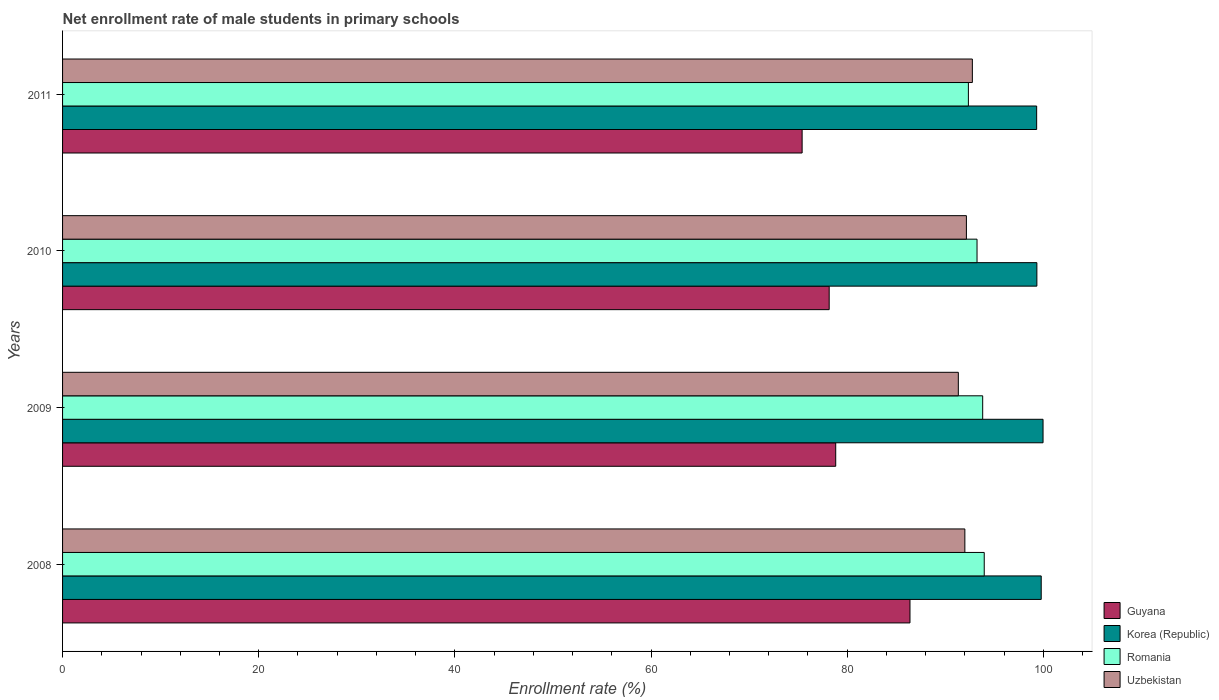Are the number of bars per tick equal to the number of legend labels?
Your answer should be very brief. Yes. Are the number of bars on each tick of the Y-axis equal?
Ensure brevity in your answer.  Yes. How many bars are there on the 2nd tick from the bottom?
Offer a terse response. 4. What is the label of the 1st group of bars from the top?
Make the answer very short. 2011. In how many cases, is the number of bars for a given year not equal to the number of legend labels?
Provide a short and direct response. 0. What is the net enrollment rate of male students in primary schools in Guyana in 2010?
Make the answer very short. 78.17. Across all years, what is the maximum net enrollment rate of male students in primary schools in Uzbekistan?
Keep it short and to the point. 92.76. Across all years, what is the minimum net enrollment rate of male students in primary schools in Romania?
Keep it short and to the point. 92.36. What is the total net enrollment rate of male students in primary schools in Uzbekistan in the graph?
Make the answer very short. 368.26. What is the difference between the net enrollment rate of male students in primary schools in Romania in 2010 and that in 2011?
Provide a succinct answer. 0.88. What is the difference between the net enrollment rate of male students in primary schools in Korea (Republic) in 2010 and the net enrollment rate of male students in primary schools in Uzbekistan in 2011?
Make the answer very short. 6.58. What is the average net enrollment rate of male students in primary schools in Guyana per year?
Your answer should be very brief. 79.7. In the year 2011, what is the difference between the net enrollment rate of male students in primary schools in Korea (Republic) and net enrollment rate of male students in primary schools in Romania?
Ensure brevity in your answer.  6.96. In how many years, is the net enrollment rate of male students in primary schools in Korea (Republic) greater than 80 %?
Provide a short and direct response. 4. What is the ratio of the net enrollment rate of male students in primary schools in Korea (Republic) in 2008 to that in 2010?
Offer a terse response. 1. Is the net enrollment rate of male students in primary schools in Uzbekistan in 2008 less than that in 2010?
Your answer should be very brief. Yes. Is the difference between the net enrollment rate of male students in primary schools in Korea (Republic) in 2009 and 2011 greater than the difference between the net enrollment rate of male students in primary schools in Romania in 2009 and 2011?
Ensure brevity in your answer.  No. What is the difference between the highest and the second highest net enrollment rate of male students in primary schools in Uzbekistan?
Ensure brevity in your answer.  0.61. What is the difference between the highest and the lowest net enrollment rate of male students in primary schools in Romania?
Make the answer very short. 1.61. Is it the case that in every year, the sum of the net enrollment rate of male students in primary schools in Korea (Republic) and net enrollment rate of male students in primary schools in Guyana is greater than the sum of net enrollment rate of male students in primary schools in Uzbekistan and net enrollment rate of male students in primary schools in Romania?
Your response must be concise. No. What does the 1st bar from the top in 2009 represents?
Give a very brief answer. Uzbekistan. How many bars are there?
Provide a short and direct response. 16. How many years are there in the graph?
Offer a very short reply. 4. What is the difference between two consecutive major ticks on the X-axis?
Your answer should be compact. 20. Does the graph contain any zero values?
Provide a short and direct response. No. Does the graph contain grids?
Offer a very short reply. No. Where does the legend appear in the graph?
Give a very brief answer. Bottom right. How many legend labels are there?
Your response must be concise. 4. What is the title of the graph?
Your answer should be compact. Net enrollment rate of male students in primary schools. Does "Middle East & North Africa (all income levels)" appear as one of the legend labels in the graph?
Give a very brief answer. No. What is the label or title of the X-axis?
Make the answer very short. Enrollment rate (%). What is the label or title of the Y-axis?
Give a very brief answer. Years. What is the Enrollment rate (%) of Guyana in 2008?
Offer a very short reply. 86.4. What is the Enrollment rate (%) of Korea (Republic) in 2008?
Make the answer very short. 99.78. What is the Enrollment rate (%) in Romania in 2008?
Offer a very short reply. 93.98. What is the Enrollment rate (%) of Uzbekistan in 2008?
Give a very brief answer. 92. What is the Enrollment rate (%) of Guyana in 2009?
Your answer should be compact. 78.83. What is the Enrollment rate (%) in Korea (Republic) in 2009?
Your response must be concise. 99.97. What is the Enrollment rate (%) in Romania in 2009?
Keep it short and to the point. 93.82. What is the Enrollment rate (%) of Uzbekistan in 2009?
Make the answer very short. 91.33. What is the Enrollment rate (%) in Guyana in 2010?
Provide a short and direct response. 78.17. What is the Enrollment rate (%) in Korea (Republic) in 2010?
Provide a succinct answer. 99.34. What is the Enrollment rate (%) in Romania in 2010?
Your answer should be very brief. 93.24. What is the Enrollment rate (%) of Uzbekistan in 2010?
Ensure brevity in your answer.  92.16. What is the Enrollment rate (%) of Guyana in 2011?
Your response must be concise. 75.41. What is the Enrollment rate (%) of Korea (Republic) in 2011?
Offer a very short reply. 99.32. What is the Enrollment rate (%) in Romania in 2011?
Provide a succinct answer. 92.36. What is the Enrollment rate (%) of Uzbekistan in 2011?
Your answer should be very brief. 92.76. Across all years, what is the maximum Enrollment rate (%) in Guyana?
Provide a succinct answer. 86.4. Across all years, what is the maximum Enrollment rate (%) of Korea (Republic)?
Give a very brief answer. 99.97. Across all years, what is the maximum Enrollment rate (%) of Romania?
Your answer should be very brief. 93.98. Across all years, what is the maximum Enrollment rate (%) of Uzbekistan?
Provide a succinct answer. 92.76. Across all years, what is the minimum Enrollment rate (%) in Guyana?
Give a very brief answer. 75.41. Across all years, what is the minimum Enrollment rate (%) of Korea (Republic)?
Provide a short and direct response. 99.32. Across all years, what is the minimum Enrollment rate (%) of Romania?
Make the answer very short. 92.36. Across all years, what is the minimum Enrollment rate (%) in Uzbekistan?
Ensure brevity in your answer.  91.33. What is the total Enrollment rate (%) in Guyana in the graph?
Make the answer very short. 318.81. What is the total Enrollment rate (%) in Korea (Republic) in the graph?
Your answer should be compact. 398.42. What is the total Enrollment rate (%) in Romania in the graph?
Ensure brevity in your answer.  373.39. What is the total Enrollment rate (%) of Uzbekistan in the graph?
Your response must be concise. 368.26. What is the difference between the Enrollment rate (%) in Guyana in 2008 and that in 2009?
Make the answer very short. 7.57. What is the difference between the Enrollment rate (%) of Korea (Republic) in 2008 and that in 2009?
Keep it short and to the point. -0.19. What is the difference between the Enrollment rate (%) in Romania in 2008 and that in 2009?
Provide a succinct answer. 0.16. What is the difference between the Enrollment rate (%) of Guyana in 2008 and that in 2010?
Give a very brief answer. 8.24. What is the difference between the Enrollment rate (%) in Korea (Republic) in 2008 and that in 2010?
Your response must be concise. 0.44. What is the difference between the Enrollment rate (%) in Romania in 2008 and that in 2010?
Provide a succinct answer. 0.74. What is the difference between the Enrollment rate (%) in Uzbekistan in 2008 and that in 2010?
Offer a terse response. -0.16. What is the difference between the Enrollment rate (%) in Guyana in 2008 and that in 2011?
Give a very brief answer. 11. What is the difference between the Enrollment rate (%) of Korea (Republic) in 2008 and that in 2011?
Your answer should be compact. 0.46. What is the difference between the Enrollment rate (%) in Romania in 2008 and that in 2011?
Your response must be concise. 1.61. What is the difference between the Enrollment rate (%) of Uzbekistan in 2008 and that in 2011?
Provide a short and direct response. -0.76. What is the difference between the Enrollment rate (%) of Guyana in 2009 and that in 2010?
Your answer should be compact. 0.67. What is the difference between the Enrollment rate (%) in Korea (Republic) in 2009 and that in 2010?
Your answer should be very brief. 0.63. What is the difference between the Enrollment rate (%) in Romania in 2009 and that in 2010?
Offer a terse response. 0.58. What is the difference between the Enrollment rate (%) of Uzbekistan in 2009 and that in 2010?
Provide a short and direct response. -0.82. What is the difference between the Enrollment rate (%) of Guyana in 2009 and that in 2011?
Provide a succinct answer. 3.43. What is the difference between the Enrollment rate (%) in Korea (Republic) in 2009 and that in 2011?
Make the answer very short. 0.65. What is the difference between the Enrollment rate (%) of Romania in 2009 and that in 2011?
Provide a succinct answer. 1.46. What is the difference between the Enrollment rate (%) in Uzbekistan in 2009 and that in 2011?
Ensure brevity in your answer.  -1.43. What is the difference between the Enrollment rate (%) of Guyana in 2010 and that in 2011?
Your answer should be very brief. 2.76. What is the difference between the Enrollment rate (%) of Korea (Republic) in 2010 and that in 2011?
Your response must be concise. 0.02. What is the difference between the Enrollment rate (%) of Romania in 2010 and that in 2011?
Offer a terse response. 0.88. What is the difference between the Enrollment rate (%) of Uzbekistan in 2010 and that in 2011?
Ensure brevity in your answer.  -0.61. What is the difference between the Enrollment rate (%) in Guyana in 2008 and the Enrollment rate (%) in Korea (Republic) in 2009?
Provide a short and direct response. -13.57. What is the difference between the Enrollment rate (%) of Guyana in 2008 and the Enrollment rate (%) of Romania in 2009?
Provide a short and direct response. -7.41. What is the difference between the Enrollment rate (%) of Guyana in 2008 and the Enrollment rate (%) of Uzbekistan in 2009?
Ensure brevity in your answer.  -4.93. What is the difference between the Enrollment rate (%) of Korea (Republic) in 2008 and the Enrollment rate (%) of Romania in 2009?
Make the answer very short. 5.97. What is the difference between the Enrollment rate (%) of Korea (Republic) in 2008 and the Enrollment rate (%) of Uzbekistan in 2009?
Make the answer very short. 8.45. What is the difference between the Enrollment rate (%) in Romania in 2008 and the Enrollment rate (%) in Uzbekistan in 2009?
Your answer should be very brief. 2.64. What is the difference between the Enrollment rate (%) of Guyana in 2008 and the Enrollment rate (%) of Korea (Republic) in 2010?
Provide a succinct answer. -12.94. What is the difference between the Enrollment rate (%) in Guyana in 2008 and the Enrollment rate (%) in Romania in 2010?
Your answer should be compact. -6.84. What is the difference between the Enrollment rate (%) in Guyana in 2008 and the Enrollment rate (%) in Uzbekistan in 2010?
Your answer should be compact. -5.75. What is the difference between the Enrollment rate (%) in Korea (Republic) in 2008 and the Enrollment rate (%) in Romania in 2010?
Make the answer very short. 6.54. What is the difference between the Enrollment rate (%) of Korea (Republic) in 2008 and the Enrollment rate (%) of Uzbekistan in 2010?
Give a very brief answer. 7.63. What is the difference between the Enrollment rate (%) of Romania in 2008 and the Enrollment rate (%) of Uzbekistan in 2010?
Provide a succinct answer. 1.82. What is the difference between the Enrollment rate (%) of Guyana in 2008 and the Enrollment rate (%) of Korea (Republic) in 2011?
Offer a terse response. -12.92. What is the difference between the Enrollment rate (%) in Guyana in 2008 and the Enrollment rate (%) in Romania in 2011?
Your answer should be very brief. -5.96. What is the difference between the Enrollment rate (%) of Guyana in 2008 and the Enrollment rate (%) of Uzbekistan in 2011?
Provide a short and direct response. -6.36. What is the difference between the Enrollment rate (%) of Korea (Republic) in 2008 and the Enrollment rate (%) of Romania in 2011?
Make the answer very short. 7.42. What is the difference between the Enrollment rate (%) in Korea (Republic) in 2008 and the Enrollment rate (%) in Uzbekistan in 2011?
Provide a short and direct response. 7.02. What is the difference between the Enrollment rate (%) of Romania in 2008 and the Enrollment rate (%) of Uzbekistan in 2011?
Your answer should be very brief. 1.21. What is the difference between the Enrollment rate (%) of Guyana in 2009 and the Enrollment rate (%) of Korea (Republic) in 2010?
Provide a succinct answer. -20.51. What is the difference between the Enrollment rate (%) of Guyana in 2009 and the Enrollment rate (%) of Romania in 2010?
Keep it short and to the point. -14.41. What is the difference between the Enrollment rate (%) in Guyana in 2009 and the Enrollment rate (%) in Uzbekistan in 2010?
Provide a succinct answer. -13.32. What is the difference between the Enrollment rate (%) in Korea (Republic) in 2009 and the Enrollment rate (%) in Romania in 2010?
Give a very brief answer. 6.73. What is the difference between the Enrollment rate (%) in Korea (Republic) in 2009 and the Enrollment rate (%) in Uzbekistan in 2010?
Your response must be concise. 7.82. What is the difference between the Enrollment rate (%) in Romania in 2009 and the Enrollment rate (%) in Uzbekistan in 2010?
Make the answer very short. 1.66. What is the difference between the Enrollment rate (%) of Guyana in 2009 and the Enrollment rate (%) of Korea (Republic) in 2011?
Give a very brief answer. -20.49. What is the difference between the Enrollment rate (%) in Guyana in 2009 and the Enrollment rate (%) in Romania in 2011?
Your answer should be very brief. -13.53. What is the difference between the Enrollment rate (%) in Guyana in 2009 and the Enrollment rate (%) in Uzbekistan in 2011?
Provide a short and direct response. -13.93. What is the difference between the Enrollment rate (%) of Korea (Republic) in 2009 and the Enrollment rate (%) of Romania in 2011?
Make the answer very short. 7.61. What is the difference between the Enrollment rate (%) in Korea (Republic) in 2009 and the Enrollment rate (%) in Uzbekistan in 2011?
Keep it short and to the point. 7.21. What is the difference between the Enrollment rate (%) of Romania in 2009 and the Enrollment rate (%) of Uzbekistan in 2011?
Provide a succinct answer. 1.05. What is the difference between the Enrollment rate (%) in Guyana in 2010 and the Enrollment rate (%) in Korea (Republic) in 2011?
Ensure brevity in your answer.  -21.15. What is the difference between the Enrollment rate (%) in Guyana in 2010 and the Enrollment rate (%) in Romania in 2011?
Make the answer very short. -14.19. What is the difference between the Enrollment rate (%) in Guyana in 2010 and the Enrollment rate (%) in Uzbekistan in 2011?
Your answer should be very brief. -14.6. What is the difference between the Enrollment rate (%) of Korea (Republic) in 2010 and the Enrollment rate (%) of Romania in 2011?
Your response must be concise. 6.98. What is the difference between the Enrollment rate (%) in Korea (Republic) in 2010 and the Enrollment rate (%) in Uzbekistan in 2011?
Your response must be concise. 6.58. What is the difference between the Enrollment rate (%) in Romania in 2010 and the Enrollment rate (%) in Uzbekistan in 2011?
Offer a terse response. 0.48. What is the average Enrollment rate (%) in Guyana per year?
Your answer should be very brief. 79.7. What is the average Enrollment rate (%) in Korea (Republic) per year?
Offer a very short reply. 99.6. What is the average Enrollment rate (%) of Romania per year?
Provide a succinct answer. 93.35. What is the average Enrollment rate (%) of Uzbekistan per year?
Ensure brevity in your answer.  92.06. In the year 2008, what is the difference between the Enrollment rate (%) of Guyana and Enrollment rate (%) of Korea (Republic)?
Provide a succinct answer. -13.38. In the year 2008, what is the difference between the Enrollment rate (%) of Guyana and Enrollment rate (%) of Romania?
Offer a very short reply. -7.57. In the year 2008, what is the difference between the Enrollment rate (%) in Guyana and Enrollment rate (%) in Uzbekistan?
Your answer should be very brief. -5.6. In the year 2008, what is the difference between the Enrollment rate (%) of Korea (Republic) and Enrollment rate (%) of Romania?
Your response must be concise. 5.81. In the year 2008, what is the difference between the Enrollment rate (%) in Korea (Republic) and Enrollment rate (%) in Uzbekistan?
Keep it short and to the point. 7.78. In the year 2008, what is the difference between the Enrollment rate (%) of Romania and Enrollment rate (%) of Uzbekistan?
Provide a succinct answer. 1.98. In the year 2009, what is the difference between the Enrollment rate (%) in Guyana and Enrollment rate (%) in Korea (Republic)?
Your response must be concise. -21.14. In the year 2009, what is the difference between the Enrollment rate (%) of Guyana and Enrollment rate (%) of Romania?
Keep it short and to the point. -14.99. In the year 2009, what is the difference between the Enrollment rate (%) of Guyana and Enrollment rate (%) of Uzbekistan?
Provide a succinct answer. -12.5. In the year 2009, what is the difference between the Enrollment rate (%) in Korea (Republic) and Enrollment rate (%) in Romania?
Keep it short and to the point. 6.15. In the year 2009, what is the difference between the Enrollment rate (%) of Korea (Republic) and Enrollment rate (%) of Uzbekistan?
Keep it short and to the point. 8.64. In the year 2009, what is the difference between the Enrollment rate (%) in Romania and Enrollment rate (%) in Uzbekistan?
Provide a short and direct response. 2.48. In the year 2010, what is the difference between the Enrollment rate (%) of Guyana and Enrollment rate (%) of Korea (Republic)?
Provide a short and direct response. -21.18. In the year 2010, what is the difference between the Enrollment rate (%) of Guyana and Enrollment rate (%) of Romania?
Provide a succinct answer. -15.07. In the year 2010, what is the difference between the Enrollment rate (%) of Guyana and Enrollment rate (%) of Uzbekistan?
Your answer should be very brief. -13.99. In the year 2010, what is the difference between the Enrollment rate (%) in Korea (Republic) and Enrollment rate (%) in Romania?
Give a very brief answer. 6.1. In the year 2010, what is the difference between the Enrollment rate (%) in Korea (Republic) and Enrollment rate (%) in Uzbekistan?
Make the answer very short. 7.19. In the year 2010, what is the difference between the Enrollment rate (%) in Romania and Enrollment rate (%) in Uzbekistan?
Your response must be concise. 1.08. In the year 2011, what is the difference between the Enrollment rate (%) in Guyana and Enrollment rate (%) in Korea (Republic)?
Make the answer very short. -23.91. In the year 2011, what is the difference between the Enrollment rate (%) of Guyana and Enrollment rate (%) of Romania?
Provide a succinct answer. -16.95. In the year 2011, what is the difference between the Enrollment rate (%) of Guyana and Enrollment rate (%) of Uzbekistan?
Give a very brief answer. -17.36. In the year 2011, what is the difference between the Enrollment rate (%) of Korea (Republic) and Enrollment rate (%) of Romania?
Offer a terse response. 6.96. In the year 2011, what is the difference between the Enrollment rate (%) in Korea (Republic) and Enrollment rate (%) in Uzbekistan?
Keep it short and to the point. 6.56. In the year 2011, what is the difference between the Enrollment rate (%) in Romania and Enrollment rate (%) in Uzbekistan?
Your answer should be very brief. -0.4. What is the ratio of the Enrollment rate (%) in Guyana in 2008 to that in 2009?
Your response must be concise. 1.1. What is the ratio of the Enrollment rate (%) of Romania in 2008 to that in 2009?
Your answer should be very brief. 1. What is the ratio of the Enrollment rate (%) in Uzbekistan in 2008 to that in 2009?
Your response must be concise. 1.01. What is the ratio of the Enrollment rate (%) of Guyana in 2008 to that in 2010?
Your answer should be compact. 1.11. What is the ratio of the Enrollment rate (%) in Korea (Republic) in 2008 to that in 2010?
Provide a short and direct response. 1. What is the ratio of the Enrollment rate (%) in Romania in 2008 to that in 2010?
Keep it short and to the point. 1.01. What is the ratio of the Enrollment rate (%) of Guyana in 2008 to that in 2011?
Provide a succinct answer. 1.15. What is the ratio of the Enrollment rate (%) of Korea (Republic) in 2008 to that in 2011?
Keep it short and to the point. 1. What is the ratio of the Enrollment rate (%) of Romania in 2008 to that in 2011?
Ensure brevity in your answer.  1.02. What is the ratio of the Enrollment rate (%) of Guyana in 2009 to that in 2010?
Offer a terse response. 1.01. What is the ratio of the Enrollment rate (%) in Romania in 2009 to that in 2010?
Your answer should be compact. 1.01. What is the ratio of the Enrollment rate (%) in Uzbekistan in 2009 to that in 2010?
Your answer should be very brief. 0.99. What is the ratio of the Enrollment rate (%) in Guyana in 2009 to that in 2011?
Offer a terse response. 1.05. What is the ratio of the Enrollment rate (%) in Korea (Republic) in 2009 to that in 2011?
Provide a short and direct response. 1.01. What is the ratio of the Enrollment rate (%) of Romania in 2009 to that in 2011?
Your answer should be very brief. 1.02. What is the ratio of the Enrollment rate (%) in Uzbekistan in 2009 to that in 2011?
Make the answer very short. 0.98. What is the ratio of the Enrollment rate (%) of Guyana in 2010 to that in 2011?
Your answer should be compact. 1.04. What is the ratio of the Enrollment rate (%) of Korea (Republic) in 2010 to that in 2011?
Make the answer very short. 1. What is the ratio of the Enrollment rate (%) of Romania in 2010 to that in 2011?
Your answer should be very brief. 1.01. What is the difference between the highest and the second highest Enrollment rate (%) of Guyana?
Keep it short and to the point. 7.57. What is the difference between the highest and the second highest Enrollment rate (%) of Korea (Republic)?
Provide a short and direct response. 0.19. What is the difference between the highest and the second highest Enrollment rate (%) of Romania?
Provide a short and direct response. 0.16. What is the difference between the highest and the second highest Enrollment rate (%) of Uzbekistan?
Your response must be concise. 0.61. What is the difference between the highest and the lowest Enrollment rate (%) of Guyana?
Your answer should be compact. 11. What is the difference between the highest and the lowest Enrollment rate (%) of Korea (Republic)?
Your answer should be very brief. 0.65. What is the difference between the highest and the lowest Enrollment rate (%) of Romania?
Provide a short and direct response. 1.61. What is the difference between the highest and the lowest Enrollment rate (%) in Uzbekistan?
Give a very brief answer. 1.43. 